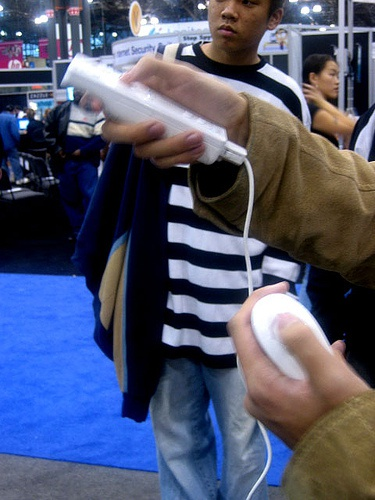Describe the objects in this image and their specific colors. I can see people in teal, black, olive, gray, and lavender tones, people in teal, black, navy, gray, and darkgray tones, remote in teal, lavender, darkgray, and gray tones, people in teal, black, navy, darkgray, and gray tones, and people in teal, black, gray, and tan tones in this image. 